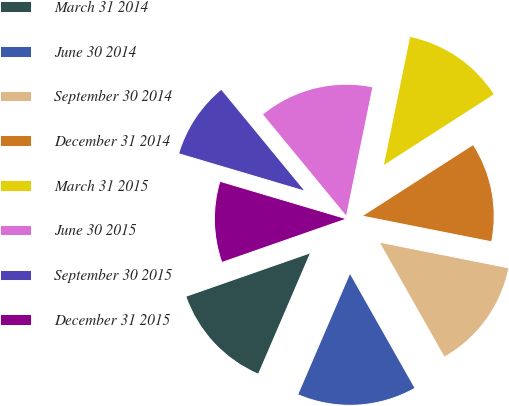Convert chart to OTSL. <chart><loc_0><loc_0><loc_500><loc_500><pie_chart><fcel>March 31 2014<fcel>June 30 2014<fcel>September 30 2014<fcel>December 31 2014<fcel>March 31 2015<fcel>June 30 2015<fcel>September 30 2015<fcel>December 31 2015<nl><fcel>13.19%<fcel>14.66%<fcel>13.68%<fcel>12.21%<fcel>12.7%<fcel>14.17%<fcel>9.45%<fcel>9.94%<nl></chart> 